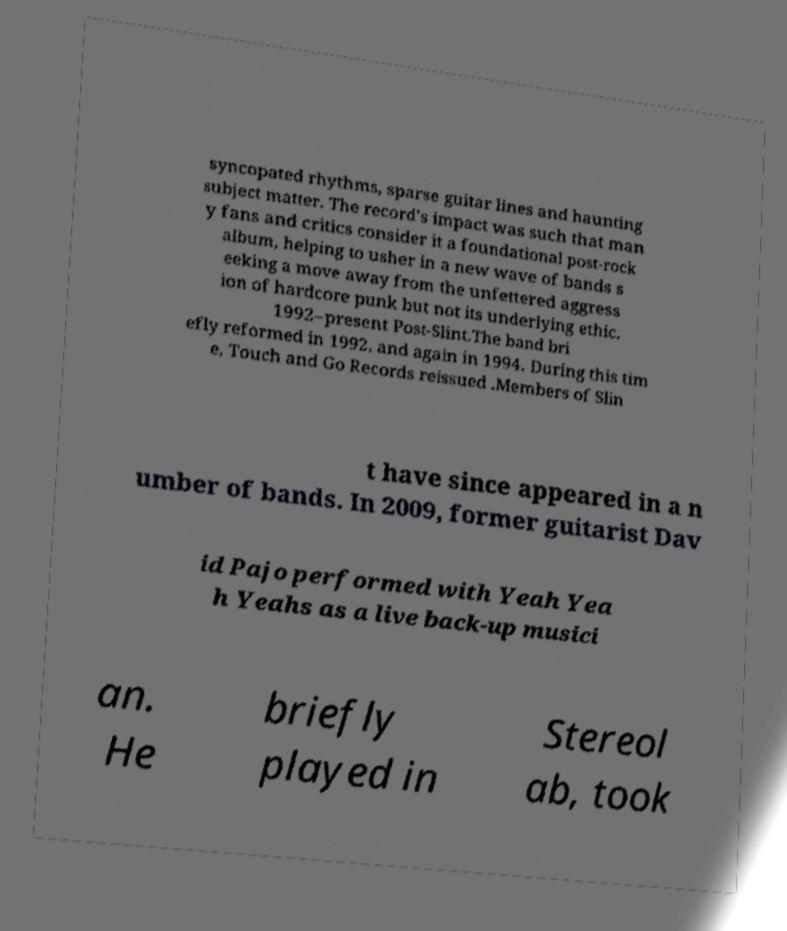Could you assist in decoding the text presented in this image and type it out clearly? syncopated rhythms, sparse guitar lines and haunting subject matter. The record's impact was such that man y fans and critics consider it a foundational post-rock album, helping to usher in a new wave of bands s eeking a move away from the unfettered aggress ion of hardcore punk but not its underlying ethic. 1992–present Post-Slint.The band bri efly reformed in 1992, and again in 1994. During this tim e, Touch and Go Records reissued .Members of Slin t have since appeared in a n umber of bands. In 2009, former guitarist Dav id Pajo performed with Yeah Yea h Yeahs as a live back-up musici an. He briefly played in Stereol ab, took 